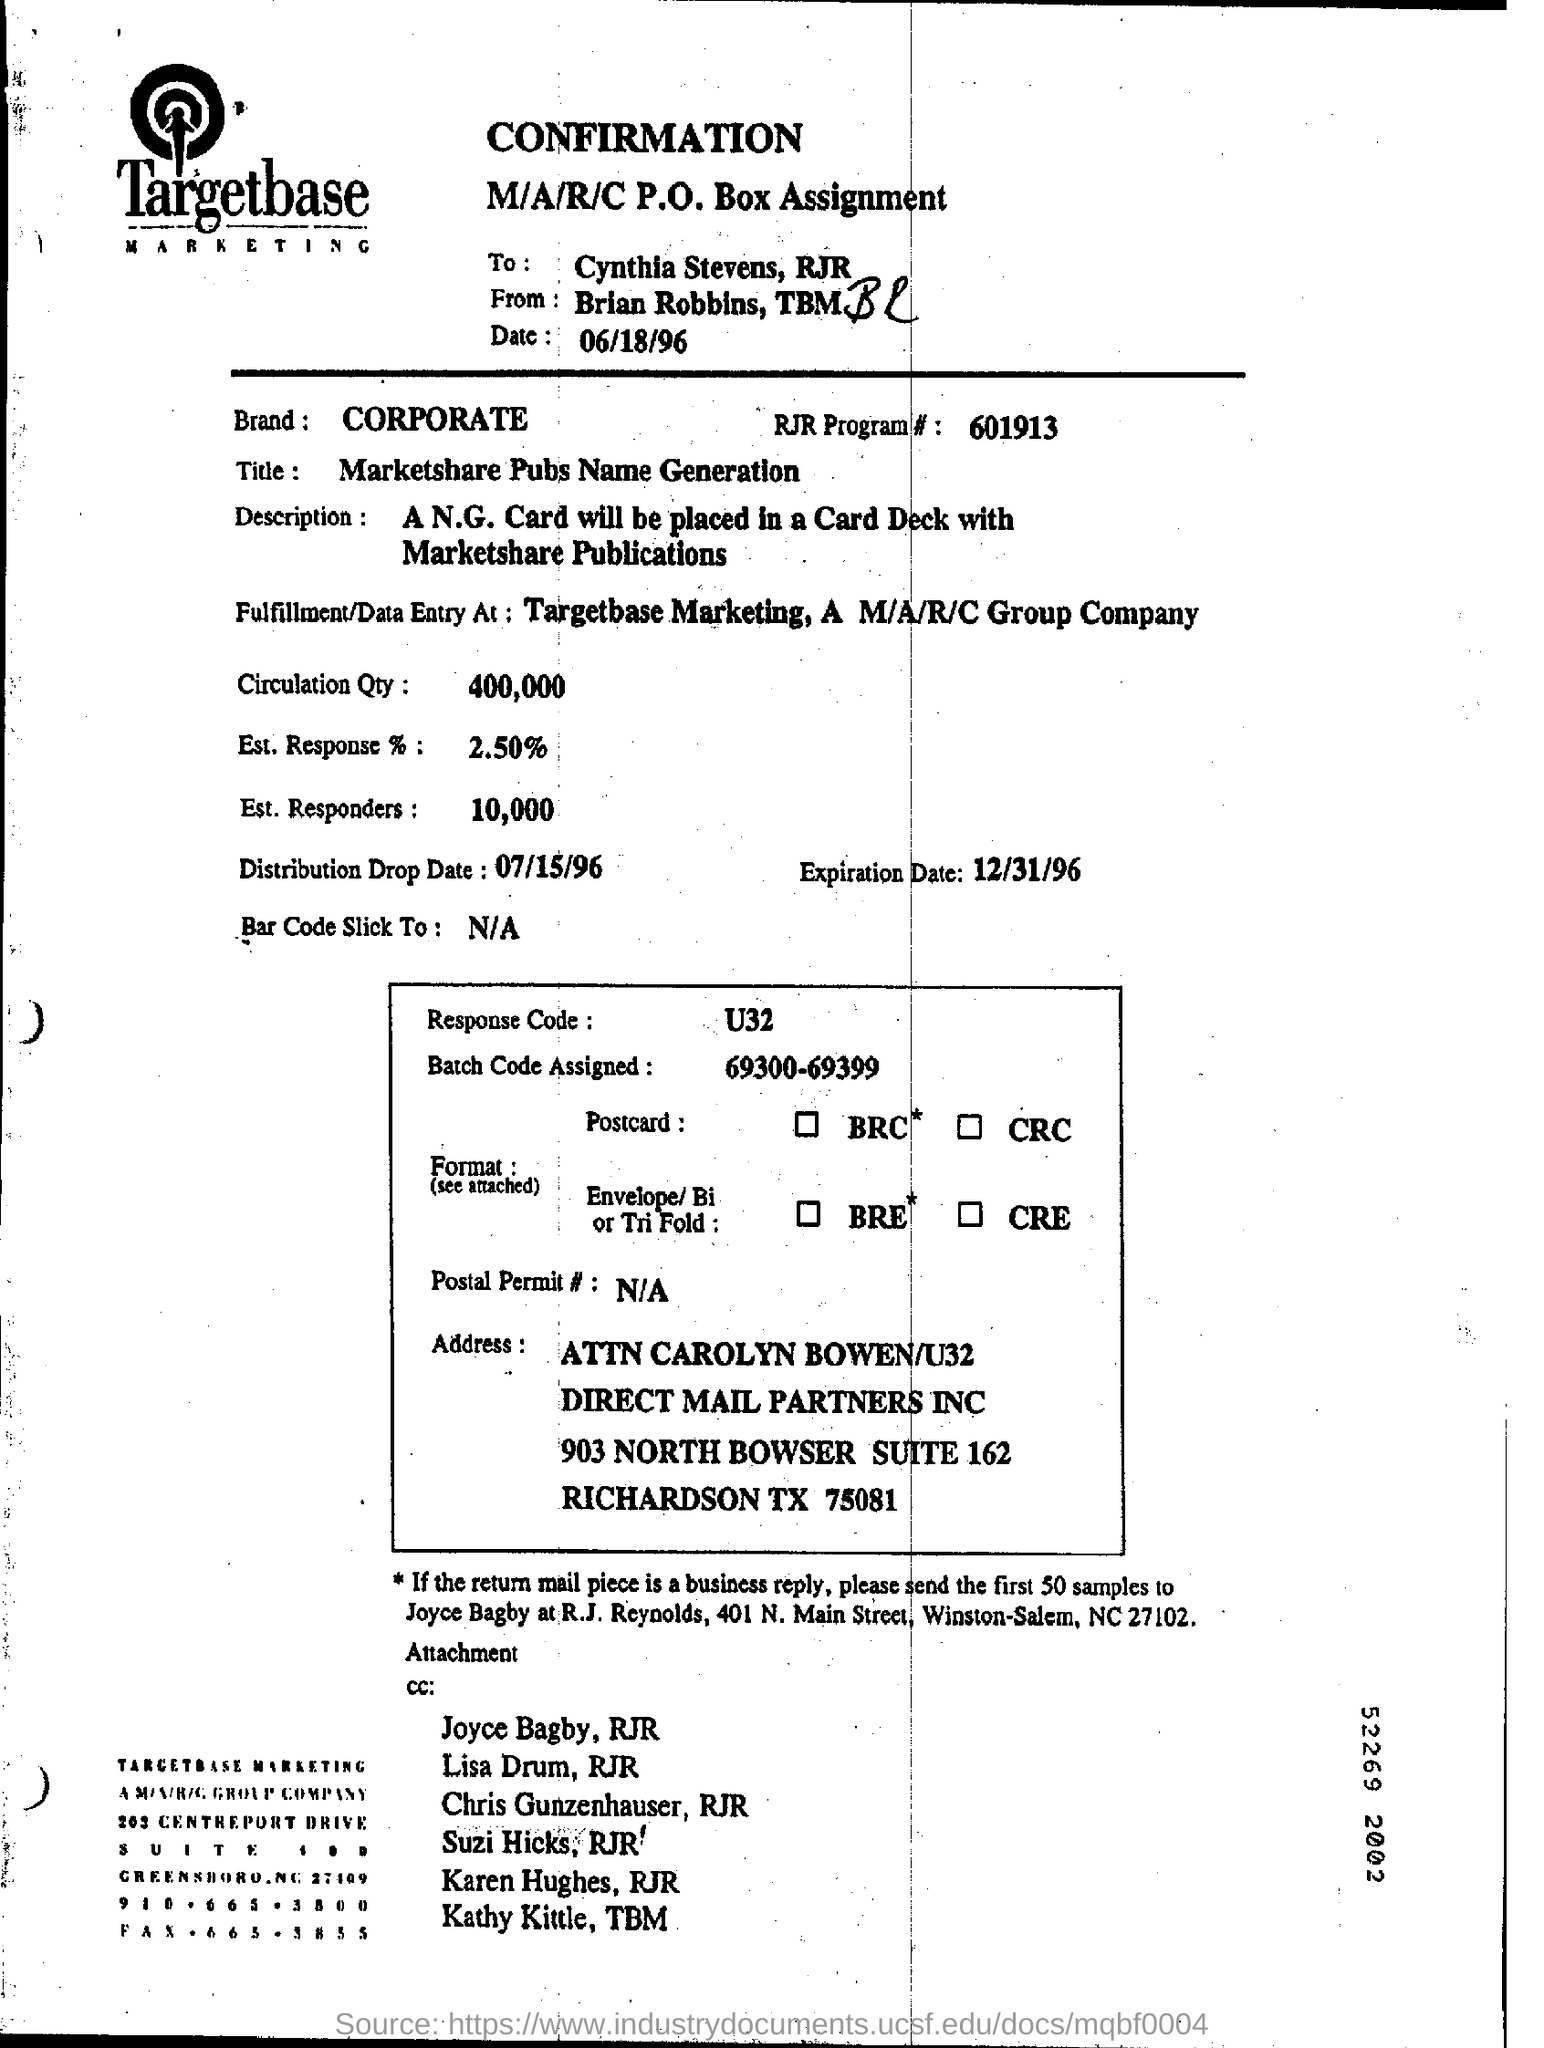Point out several critical features in this image. According to the document, an estimated 10,000 responders are present. The company name mentioned in the letterhead is Targetbase Marketing. The expiration date mentioned in the document is December 31, 1996. According to the document, the estimated response rate is approximately 2.50%. The circulation quantity, as stated in the document, is 400,000. 